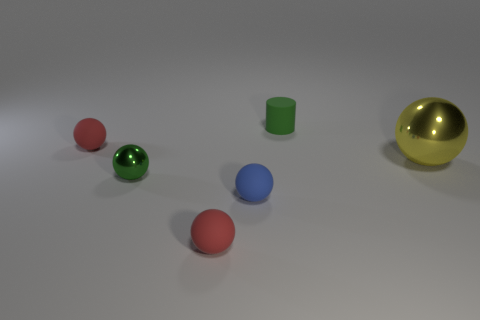Subtract 1 spheres. How many spheres are left? 4 Subtract all blue balls. How many balls are left? 4 Subtract all small green spheres. How many spheres are left? 4 Subtract all brown balls. Subtract all purple cylinders. How many balls are left? 5 Add 3 red objects. How many objects exist? 9 Subtract all balls. How many objects are left? 1 Subtract all yellow shiny balls. Subtract all green metallic spheres. How many objects are left? 4 Add 2 yellow objects. How many yellow objects are left? 3 Add 3 big gray rubber things. How many big gray rubber things exist? 3 Subtract 0 cyan cubes. How many objects are left? 6 